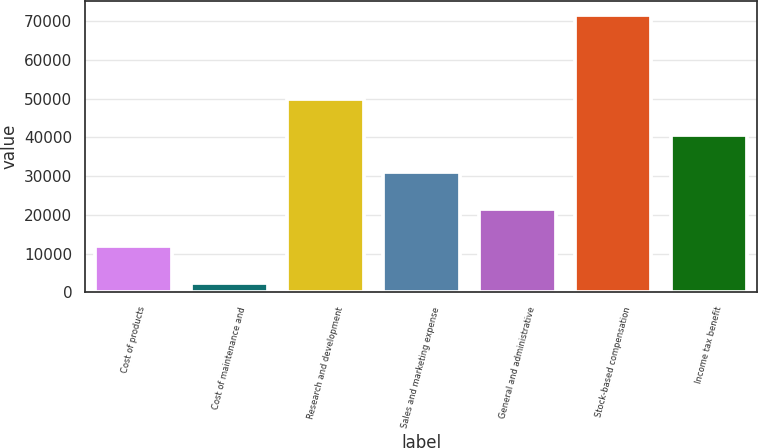Convert chart. <chart><loc_0><loc_0><loc_500><loc_500><bar_chart><fcel>Cost of products<fcel>Cost of maintenance and<fcel>Research and development<fcel>Sales and marketing expense<fcel>General and administrative<fcel>Stock-based compensation<fcel>Income tax benefit<nl><fcel>11934.5<fcel>2418<fcel>50000.5<fcel>30967.5<fcel>21451<fcel>71616<fcel>40484<nl></chart> 